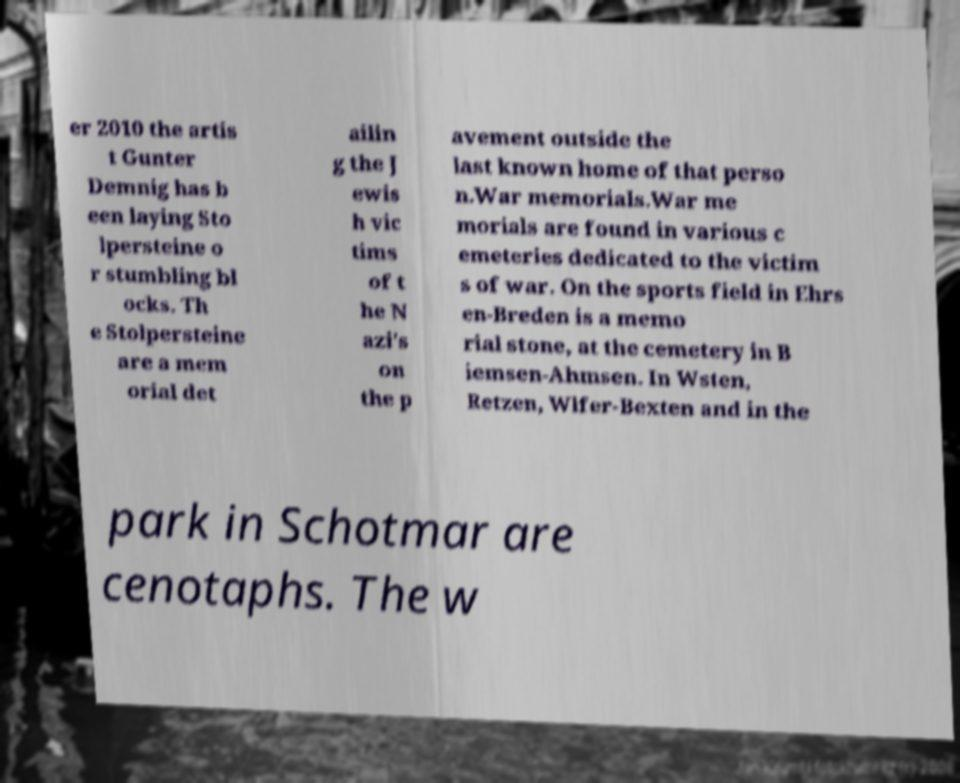Could you assist in decoding the text presented in this image and type it out clearly? er 2010 the artis t Gunter Demnig has b een laying Sto lpersteine o r stumbling bl ocks. Th e Stolpersteine are a mem orial det ailin g the J ewis h vic tims of t he N azi's on the p avement outside the last known home of that perso n.War memorials.War me morials are found in various c emeteries dedicated to the victim s of war. On the sports field in Ehrs en-Breden is a memo rial stone, at the cemetery in B iemsen-Ahmsen. In Wsten, Retzen, Wlfer-Bexten and in the park in Schotmar are cenotaphs. The w 